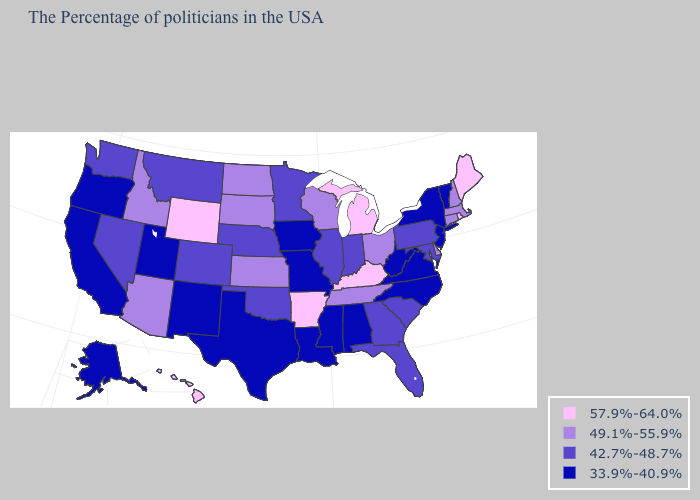Among the states that border New Mexico , which have the highest value?
Be succinct. Arizona. What is the highest value in the USA?
Answer briefly. 57.9%-64.0%. Name the states that have a value in the range 33.9%-40.9%?
Concise answer only. Vermont, New York, New Jersey, Virginia, North Carolina, West Virginia, Alabama, Mississippi, Louisiana, Missouri, Iowa, Texas, New Mexico, Utah, California, Oregon, Alaska. What is the value of New Hampshire?
Keep it brief. 49.1%-55.9%. What is the highest value in the MidWest ?
Answer briefly. 57.9%-64.0%. Which states have the lowest value in the USA?
Short answer required. Vermont, New York, New Jersey, Virginia, North Carolina, West Virginia, Alabama, Mississippi, Louisiana, Missouri, Iowa, Texas, New Mexico, Utah, California, Oregon, Alaska. Among the states that border Indiana , does Michigan have the highest value?
Concise answer only. Yes. What is the lowest value in the USA?
Concise answer only. 33.9%-40.9%. Does Oregon have the lowest value in the West?
Answer briefly. Yes. Name the states that have a value in the range 42.7%-48.7%?
Keep it brief. Maryland, Pennsylvania, South Carolina, Florida, Georgia, Indiana, Illinois, Minnesota, Nebraska, Oklahoma, Colorado, Montana, Nevada, Washington. Which states have the lowest value in the USA?
Give a very brief answer. Vermont, New York, New Jersey, Virginia, North Carolina, West Virginia, Alabama, Mississippi, Louisiana, Missouri, Iowa, Texas, New Mexico, Utah, California, Oregon, Alaska. Does the first symbol in the legend represent the smallest category?
Short answer required. No. What is the lowest value in the USA?
Answer briefly. 33.9%-40.9%. What is the lowest value in the South?
Be succinct. 33.9%-40.9%. What is the lowest value in states that border Maine?
Short answer required. 49.1%-55.9%. 